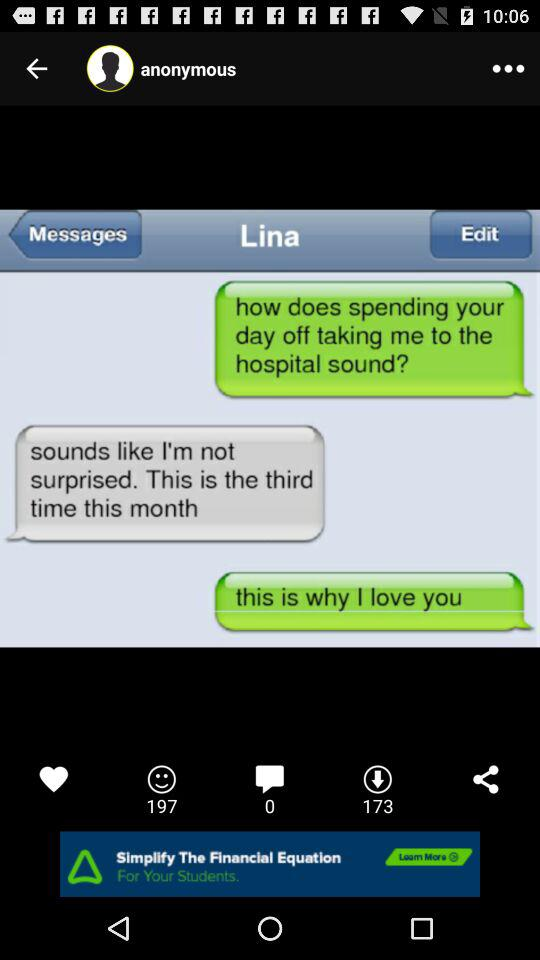What is the number of dislikes?
When the provided information is insufficient, respond with <no answer>. <no answer> 